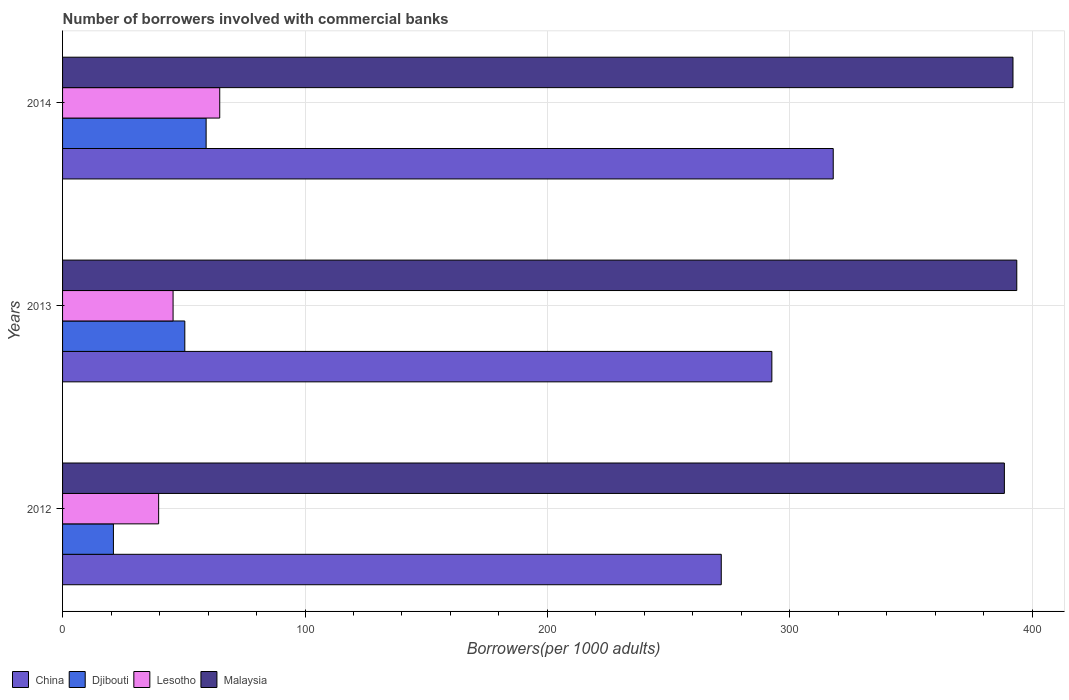How many different coloured bars are there?
Your answer should be very brief. 4. How many groups of bars are there?
Your response must be concise. 3. Are the number of bars on each tick of the Y-axis equal?
Provide a succinct answer. Yes. What is the label of the 1st group of bars from the top?
Your answer should be very brief. 2014. In how many cases, is the number of bars for a given year not equal to the number of legend labels?
Your answer should be very brief. 0. What is the number of borrowers involved with commercial banks in Djibouti in 2012?
Your response must be concise. 20.98. Across all years, what is the maximum number of borrowers involved with commercial banks in Djibouti?
Ensure brevity in your answer.  59.22. Across all years, what is the minimum number of borrowers involved with commercial banks in Djibouti?
Offer a terse response. 20.98. In which year was the number of borrowers involved with commercial banks in Lesotho minimum?
Give a very brief answer. 2012. What is the total number of borrowers involved with commercial banks in Lesotho in the graph?
Your answer should be very brief. 150.05. What is the difference between the number of borrowers involved with commercial banks in Djibouti in 2013 and that in 2014?
Provide a short and direct response. -8.79. What is the difference between the number of borrowers involved with commercial banks in Malaysia in 2013 and the number of borrowers involved with commercial banks in Djibouti in 2012?
Give a very brief answer. 372.63. What is the average number of borrowers involved with commercial banks in Djibouti per year?
Ensure brevity in your answer.  43.54. In the year 2013, what is the difference between the number of borrowers involved with commercial banks in Lesotho and number of borrowers involved with commercial banks in Malaysia?
Ensure brevity in your answer.  -348.03. In how many years, is the number of borrowers involved with commercial banks in Lesotho greater than 180 ?
Offer a terse response. 0. What is the ratio of the number of borrowers involved with commercial banks in China in 2012 to that in 2014?
Keep it short and to the point. 0.85. Is the number of borrowers involved with commercial banks in Djibouti in 2012 less than that in 2013?
Give a very brief answer. Yes. What is the difference between the highest and the second highest number of borrowers involved with commercial banks in Lesotho?
Offer a terse response. 19.24. What is the difference between the highest and the lowest number of borrowers involved with commercial banks in Djibouti?
Your response must be concise. 38.24. Is the sum of the number of borrowers involved with commercial banks in Lesotho in 2012 and 2014 greater than the maximum number of borrowers involved with commercial banks in Djibouti across all years?
Your answer should be compact. Yes. Is it the case that in every year, the sum of the number of borrowers involved with commercial banks in China and number of borrowers involved with commercial banks in Lesotho is greater than the sum of number of borrowers involved with commercial banks in Malaysia and number of borrowers involved with commercial banks in Djibouti?
Keep it short and to the point. No. What does the 2nd bar from the top in 2013 represents?
Provide a short and direct response. Lesotho. What does the 1st bar from the bottom in 2013 represents?
Provide a succinct answer. China. Are all the bars in the graph horizontal?
Make the answer very short. Yes. What is the difference between two consecutive major ticks on the X-axis?
Provide a short and direct response. 100. Are the values on the major ticks of X-axis written in scientific E-notation?
Your answer should be very brief. No. Does the graph contain any zero values?
Your response must be concise. No. Does the graph contain grids?
Provide a short and direct response. Yes. How many legend labels are there?
Provide a short and direct response. 4. How are the legend labels stacked?
Make the answer very short. Horizontal. What is the title of the graph?
Your answer should be compact. Number of borrowers involved with commercial banks. What is the label or title of the X-axis?
Your answer should be compact. Borrowers(per 1000 adults). What is the label or title of the Y-axis?
Offer a very short reply. Years. What is the Borrowers(per 1000 adults) of China in 2012?
Give a very brief answer. 271.71. What is the Borrowers(per 1000 adults) of Djibouti in 2012?
Offer a very short reply. 20.98. What is the Borrowers(per 1000 adults) in Lesotho in 2012?
Make the answer very short. 39.63. What is the Borrowers(per 1000 adults) in Malaysia in 2012?
Provide a short and direct response. 388.49. What is the Borrowers(per 1000 adults) of China in 2013?
Offer a very short reply. 292.58. What is the Borrowers(per 1000 adults) in Djibouti in 2013?
Provide a succinct answer. 50.43. What is the Borrowers(per 1000 adults) in Lesotho in 2013?
Offer a terse response. 45.58. What is the Borrowers(per 1000 adults) of Malaysia in 2013?
Ensure brevity in your answer.  393.61. What is the Borrowers(per 1000 adults) of China in 2014?
Offer a terse response. 317.9. What is the Borrowers(per 1000 adults) in Djibouti in 2014?
Give a very brief answer. 59.22. What is the Borrowers(per 1000 adults) of Lesotho in 2014?
Offer a terse response. 64.83. What is the Borrowers(per 1000 adults) of Malaysia in 2014?
Your answer should be compact. 392.05. Across all years, what is the maximum Borrowers(per 1000 adults) of China?
Ensure brevity in your answer.  317.9. Across all years, what is the maximum Borrowers(per 1000 adults) in Djibouti?
Provide a short and direct response. 59.22. Across all years, what is the maximum Borrowers(per 1000 adults) in Lesotho?
Give a very brief answer. 64.83. Across all years, what is the maximum Borrowers(per 1000 adults) of Malaysia?
Provide a succinct answer. 393.61. Across all years, what is the minimum Borrowers(per 1000 adults) of China?
Your answer should be very brief. 271.71. Across all years, what is the minimum Borrowers(per 1000 adults) in Djibouti?
Keep it short and to the point. 20.98. Across all years, what is the minimum Borrowers(per 1000 adults) in Lesotho?
Ensure brevity in your answer.  39.63. Across all years, what is the minimum Borrowers(per 1000 adults) of Malaysia?
Your answer should be very brief. 388.49. What is the total Borrowers(per 1000 adults) in China in the graph?
Offer a very short reply. 882.19. What is the total Borrowers(per 1000 adults) in Djibouti in the graph?
Provide a short and direct response. 130.63. What is the total Borrowers(per 1000 adults) in Lesotho in the graph?
Your answer should be compact. 150.05. What is the total Borrowers(per 1000 adults) of Malaysia in the graph?
Ensure brevity in your answer.  1174.15. What is the difference between the Borrowers(per 1000 adults) in China in 2012 and that in 2013?
Offer a very short reply. -20.87. What is the difference between the Borrowers(per 1000 adults) of Djibouti in 2012 and that in 2013?
Your answer should be very brief. -29.45. What is the difference between the Borrowers(per 1000 adults) of Lesotho in 2012 and that in 2013?
Provide a short and direct response. -5.95. What is the difference between the Borrowers(per 1000 adults) in Malaysia in 2012 and that in 2013?
Give a very brief answer. -5.12. What is the difference between the Borrowers(per 1000 adults) of China in 2012 and that in 2014?
Your answer should be very brief. -46.19. What is the difference between the Borrowers(per 1000 adults) of Djibouti in 2012 and that in 2014?
Make the answer very short. -38.24. What is the difference between the Borrowers(per 1000 adults) of Lesotho in 2012 and that in 2014?
Provide a short and direct response. -25.2. What is the difference between the Borrowers(per 1000 adults) in Malaysia in 2012 and that in 2014?
Your response must be concise. -3.55. What is the difference between the Borrowers(per 1000 adults) in China in 2013 and that in 2014?
Give a very brief answer. -25.32. What is the difference between the Borrowers(per 1000 adults) of Djibouti in 2013 and that in 2014?
Keep it short and to the point. -8.79. What is the difference between the Borrowers(per 1000 adults) of Lesotho in 2013 and that in 2014?
Your response must be concise. -19.24. What is the difference between the Borrowers(per 1000 adults) of Malaysia in 2013 and that in 2014?
Give a very brief answer. 1.57. What is the difference between the Borrowers(per 1000 adults) of China in 2012 and the Borrowers(per 1000 adults) of Djibouti in 2013?
Ensure brevity in your answer.  221.28. What is the difference between the Borrowers(per 1000 adults) in China in 2012 and the Borrowers(per 1000 adults) in Lesotho in 2013?
Offer a very short reply. 226.13. What is the difference between the Borrowers(per 1000 adults) of China in 2012 and the Borrowers(per 1000 adults) of Malaysia in 2013?
Give a very brief answer. -121.9. What is the difference between the Borrowers(per 1000 adults) of Djibouti in 2012 and the Borrowers(per 1000 adults) of Lesotho in 2013?
Provide a short and direct response. -24.61. What is the difference between the Borrowers(per 1000 adults) of Djibouti in 2012 and the Borrowers(per 1000 adults) of Malaysia in 2013?
Offer a very short reply. -372.63. What is the difference between the Borrowers(per 1000 adults) of Lesotho in 2012 and the Borrowers(per 1000 adults) of Malaysia in 2013?
Keep it short and to the point. -353.98. What is the difference between the Borrowers(per 1000 adults) of China in 2012 and the Borrowers(per 1000 adults) of Djibouti in 2014?
Provide a short and direct response. 212.49. What is the difference between the Borrowers(per 1000 adults) in China in 2012 and the Borrowers(per 1000 adults) in Lesotho in 2014?
Offer a terse response. 206.88. What is the difference between the Borrowers(per 1000 adults) in China in 2012 and the Borrowers(per 1000 adults) in Malaysia in 2014?
Your response must be concise. -120.33. What is the difference between the Borrowers(per 1000 adults) in Djibouti in 2012 and the Borrowers(per 1000 adults) in Lesotho in 2014?
Make the answer very short. -43.85. What is the difference between the Borrowers(per 1000 adults) in Djibouti in 2012 and the Borrowers(per 1000 adults) in Malaysia in 2014?
Give a very brief answer. -371.07. What is the difference between the Borrowers(per 1000 adults) of Lesotho in 2012 and the Borrowers(per 1000 adults) of Malaysia in 2014?
Provide a succinct answer. -352.41. What is the difference between the Borrowers(per 1000 adults) in China in 2013 and the Borrowers(per 1000 adults) in Djibouti in 2014?
Make the answer very short. 233.36. What is the difference between the Borrowers(per 1000 adults) in China in 2013 and the Borrowers(per 1000 adults) in Lesotho in 2014?
Ensure brevity in your answer.  227.75. What is the difference between the Borrowers(per 1000 adults) in China in 2013 and the Borrowers(per 1000 adults) in Malaysia in 2014?
Offer a terse response. -99.46. What is the difference between the Borrowers(per 1000 adults) in Djibouti in 2013 and the Borrowers(per 1000 adults) in Lesotho in 2014?
Ensure brevity in your answer.  -14.4. What is the difference between the Borrowers(per 1000 adults) of Djibouti in 2013 and the Borrowers(per 1000 adults) of Malaysia in 2014?
Provide a succinct answer. -341.62. What is the difference between the Borrowers(per 1000 adults) in Lesotho in 2013 and the Borrowers(per 1000 adults) in Malaysia in 2014?
Give a very brief answer. -346.46. What is the average Borrowers(per 1000 adults) of China per year?
Your answer should be compact. 294.06. What is the average Borrowers(per 1000 adults) in Djibouti per year?
Your answer should be very brief. 43.54. What is the average Borrowers(per 1000 adults) of Lesotho per year?
Make the answer very short. 50.02. What is the average Borrowers(per 1000 adults) of Malaysia per year?
Your response must be concise. 391.38. In the year 2012, what is the difference between the Borrowers(per 1000 adults) in China and Borrowers(per 1000 adults) in Djibouti?
Your answer should be compact. 250.73. In the year 2012, what is the difference between the Borrowers(per 1000 adults) of China and Borrowers(per 1000 adults) of Lesotho?
Provide a short and direct response. 232.08. In the year 2012, what is the difference between the Borrowers(per 1000 adults) of China and Borrowers(per 1000 adults) of Malaysia?
Make the answer very short. -116.78. In the year 2012, what is the difference between the Borrowers(per 1000 adults) in Djibouti and Borrowers(per 1000 adults) in Lesotho?
Your response must be concise. -18.65. In the year 2012, what is the difference between the Borrowers(per 1000 adults) in Djibouti and Borrowers(per 1000 adults) in Malaysia?
Offer a very short reply. -367.51. In the year 2012, what is the difference between the Borrowers(per 1000 adults) of Lesotho and Borrowers(per 1000 adults) of Malaysia?
Your answer should be compact. -348.86. In the year 2013, what is the difference between the Borrowers(per 1000 adults) in China and Borrowers(per 1000 adults) in Djibouti?
Provide a short and direct response. 242.16. In the year 2013, what is the difference between the Borrowers(per 1000 adults) in China and Borrowers(per 1000 adults) in Lesotho?
Give a very brief answer. 247. In the year 2013, what is the difference between the Borrowers(per 1000 adults) in China and Borrowers(per 1000 adults) in Malaysia?
Make the answer very short. -101.03. In the year 2013, what is the difference between the Borrowers(per 1000 adults) of Djibouti and Borrowers(per 1000 adults) of Lesotho?
Keep it short and to the point. 4.84. In the year 2013, what is the difference between the Borrowers(per 1000 adults) in Djibouti and Borrowers(per 1000 adults) in Malaysia?
Give a very brief answer. -343.18. In the year 2013, what is the difference between the Borrowers(per 1000 adults) of Lesotho and Borrowers(per 1000 adults) of Malaysia?
Ensure brevity in your answer.  -348.03. In the year 2014, what is the difference between the Borrowers(per 1000 adults) of China and Borrowers(per 1000 adults) of Djibouti?
Your answer should be very brief. 258.68. In the year 2014, what is the difference between the Borrowers(per 1000 adults) in China and Borrowers(per 1000 adults) in Lesotho?
Make the answer very short. 253.07. In the year 2014, what is the difference between the Borrowers(per 1000 adults) of China and Borrowers(per 1000 adults) of Malaysia?
Offer a very short reply. -74.14. In the year 2014, what is the difference between the Borrowers(per 1000 adults) of Djibouti and Borrowers(per 1000 adults) of Lesotho?
Provide a short and direct response. -5.61. In the year 2014, what is the difference between the Borrowers(per 1000 adults) of Djibouti and Borrowers(per 1000 adults) of Malaysia?
Give a very brief answer. -332.83. In the year 2014, what is the difference between the Borrowers(per 1000 adults) of Lesotho and Borrowers(per 1000 adults) of Malaysia?
Your answer should be very brief. -327.22. What is the ratio of the Borrowers(per 1000 adults) of China in 2012 to that in 2013?
Keep it short and to the point. 0.93. What is the ratio of the Borrowers(per 1000 adults) in Djibouti in 2012 to that in 2013?
Ensure brevity in your answer.  0.42. What is the ratio of the Borrowers(per 1000 adults) of Lesotho in 2012 to that in 2013?
Make the answer very short. 0.87. What is the ratio of the Borrowers(per 1000 adults) in China in 2012 to that in 2014?
Provide a succinct answer. 0.85. What is the ratio of the Borrowers(per 1000 adults) of Djibouti in 2012 to that in 2014?
Your response must be concise. 0.35. What is the ratio of the Borrowers(per 1000 adults) in Lesotho in 2012 to that in 2014?
Provide a short and direct response. 0.61. What is the ratio of the Borrowers(per 1000 adults) in Malaysia in 2012 to that in 2014?
Your answer should be very brief. 0.99. What is the ratio of the Borrowers(per 1000 adults) of China in 2013 to that in 2014?
Make the answer very short. 0.92. What is the ratio of the Borrowers(per 1000 adults) in Djibouti in 2013 to that in 2014?
Give a very brief answer. 0.85. What is the ratio of the Borrowers(per 1000 adults) of Lesotho in 2013 to that in 2014?
Your answer should be very brief. 0.7. What is the difference between the highest and the second highest Borrowers(per 1000 adults) of China?
Make the answer very short. 25.32. What is the difference between the highest and the second highest Borrowers(per 1000 adults) in Djibouti?
Your response must be concise. 8.79. What is the difference between the highest and the second highest Borrowers(per 1000 adults) in Lesotho?
Ensure brevity in your answer.  19.24. What is the difference between the highest and the second highest Borrowers(per 1000 adults) of Malaysia?
Give a very brief answer. 1.57. What is the difference between the highest and the lowest Borrowers(per 1000 adults) in China?
Make the answer very short. 46.19. What is the difference between the highest and the lowest Borrowers(per 1000 adults) in Djibouti?
Your answer should be very brief. 38.24. What is the difference between the highest and the lowest Borrowers(per 1000 adults) in Lesotho?
Your answer should be very brief. 25.2. What is the difference between the highest and the lowest Borrowers(per 1000 adults) of Malaysia?
Offer a very short reply. 5.12. 